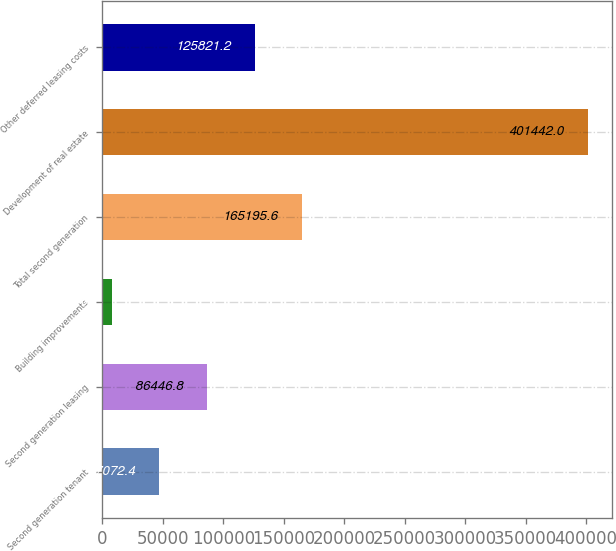Convert chart. <chart><loc_0><loc_0><loc_500><loc_500><bar_chart><fcel>Second generation tenant<fcel>Second generation leasing<fcel>Building improvements<fcel>Total second generation<fcel>Development of real estate<fcel>Other deferred leasing costs<nl><fcel>47072.4<fcel>86446.8<fcel>7698<fcel>165196<fcel>401442<fcel>125821<nl></chart> 